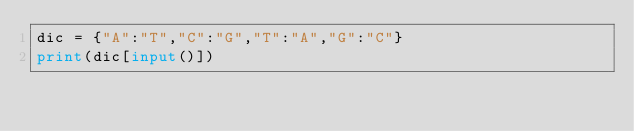<code> <loc_0><loc_0><loc_500><loc_500><_Python_>dic = {"A":"T","C":"G","T":"A","G":"C"}
print(dic[input()])</code> 